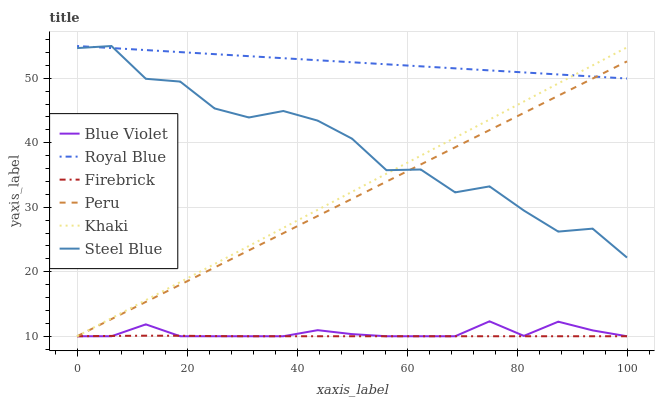Does Firebrick have the minimum area under the curve?
Answer yes or no. Yes. Does Royal Blue have the maximum area under the curve?
Answer yes or no. Yes. Does Steel Blue have the minimum area under the curve?
Answer yes or no. No. Does Steel Blue have the maximum area under the curve?
Answer yes or no. No. Is Khaki the smoothest?
Answer yes or no. Yes. Is Steel Blue the roughest?
Answer yes or no. Yes. Is Firebrick the smoothest?
Answer yes or no. No. Is Firebrick the roughest?
Answer yes or no. No. Does Khaki have the lowest value?
Answer yes or no. Yes. Does Steel Blue have the lowest value?
Answer yes or no. No. Does Royal Blue have the highest value?
Answer yes or no. Yes. Does Firebrick have the highest value?
Answer yes or no. No. Is Blue Violet less than Royal Blue?
Answer yes or no. Yes. Is Steel Blue greater than Blue Violet?
Answer yes or no. Yes. Does Peru intersect Firebrick?
Answer yes or no. Yes. Is Peru less than Firebrick?
Answer yes or no. No. Is Peru greater than Firebrick?
Answer yes or no. No. Does Blue Violet intersect Royal Blue?
Answer yes or no. No. 